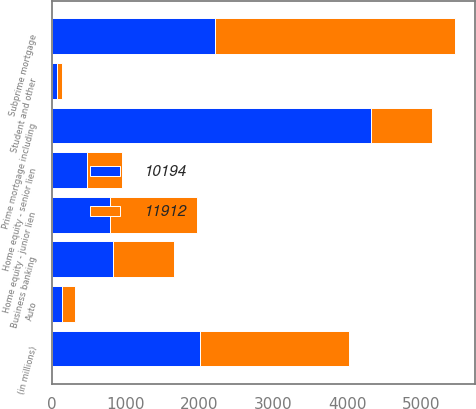Convert chart. <chart><loc_0><loc_0><loc_500><loc_500><stacked_bar_chart><ecel><fcel>(in millions)<fcel>Home equity - senior lien<fcel>Home equity - junior lien<fcel>Prime mortgage including<fcel>Subprime mortgage<fcel>Auto<fcel>Business banking<fcel>Student and other<nl><fcel>10194<fcel>2010<fcel>479<fcel>784<fcel>4320<fcel>2210<fcel>141<fcel>832<fcel>67<nl><fcel>11912<fcel>2009<fcel>477<fcel>1188<fcel>826<fcel>3248<fcel>177<fcel>826<fcel>74<nl></chart> 